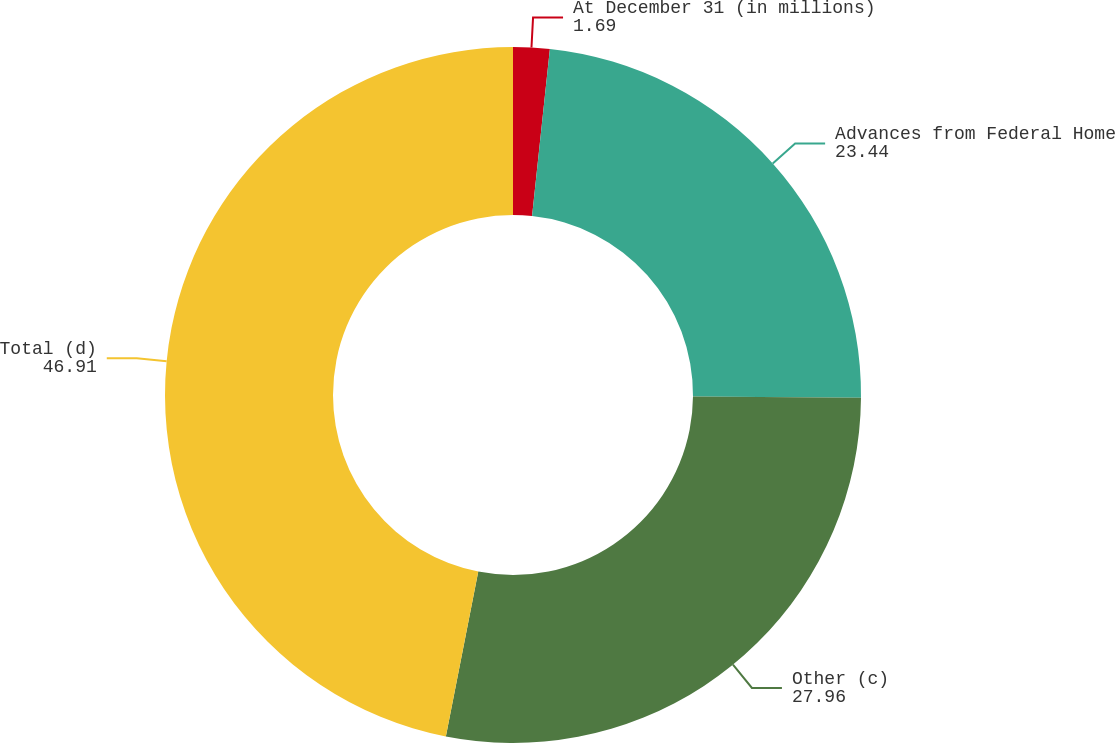Convert chart. <chart><loc_0><loc_0><loc_500><loc_500><pie_chart><fcel>At December 31 (in millions)<fcel>Advances from Federal Home<fcel>Other (c)<fcel>Total (d)<nl><fcel>1.69%<fcel>23.44%<fcel>27.96%<fcel>46.91%<nl></chart> 